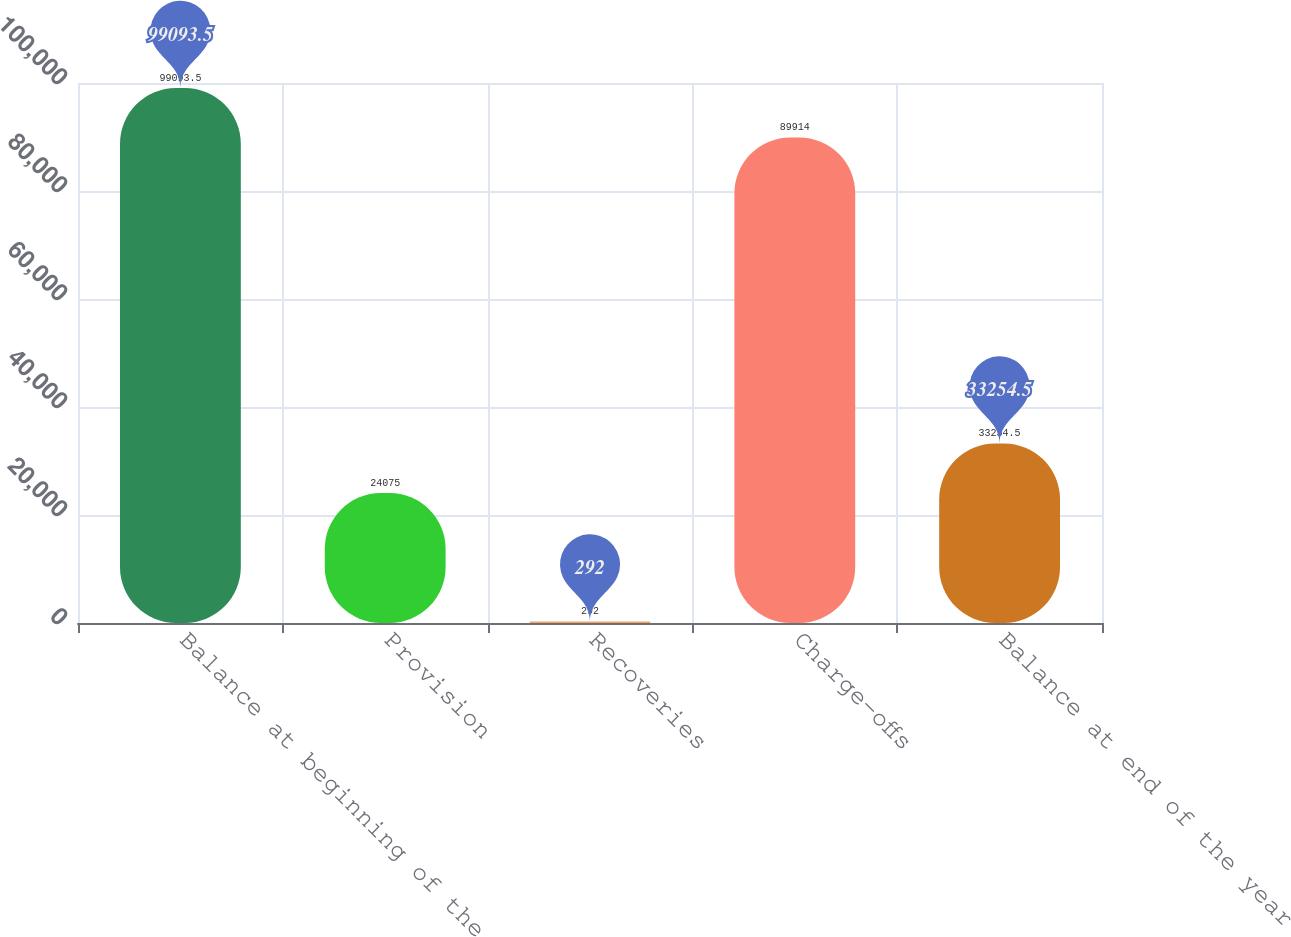Convert chart to OTSL. <chart><loc_0><loc_0><loc_500><loc_500><bar_chart><fcel>Balance at beginning of the<fcel>Provision<fcel>Recoveries<fcel>Charge-offs<fcel>Balance at end of the year<nl><fcel>99093.5<fcel>24075<fcel>292<fcel>89914<fcel>33254.5<nl></chart> 